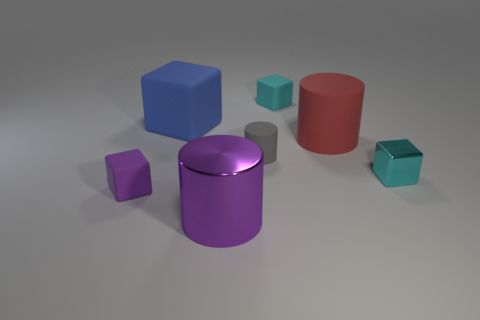Is the number of big objects that are in front of the red object greater than the number of tiny rubber objects behind the tiny cyan shiny thing?
Provide a short and direct response. No. There is a tiny thing left of the big purple cylinder; is it the same color as the small cube that is to the right of the big matte cylinder?
Keep it short and to the point. No. What size is the purple thing that is to the left of the large thing behind the big object that is on the right side of the shiny cylinder?
Your answer should be compact. Small. There is a big matte thing that is the same shape as the small purple matte thing; what is its color?
Provide a short and direct response. Blue. Is the number of small rubber things that are behind the gray rubber cylinder greater than the number of big red rubber cylinders?
Ensure brevity in your answer.  No. There is a big purple metallic thing; is it the same shape as the shiny thing that is behind the small purple block?
Provide a succinct answer. No. There is a gray matte object that is the same shape as the large metallic object; what size is it?
Give a very brief answer. Small. Is the number of cyan blocks greater than the number of big cyan rubber cylinders?
Your answer should be compact. Yes. Do the small gray object and the red thing have the same shape?
Your response must be concise. Yes. There is a small block that is in front of the metallic object on the right side of the cyan matte cube; what is it made of?
Provide a succinct answer. Rubber. 